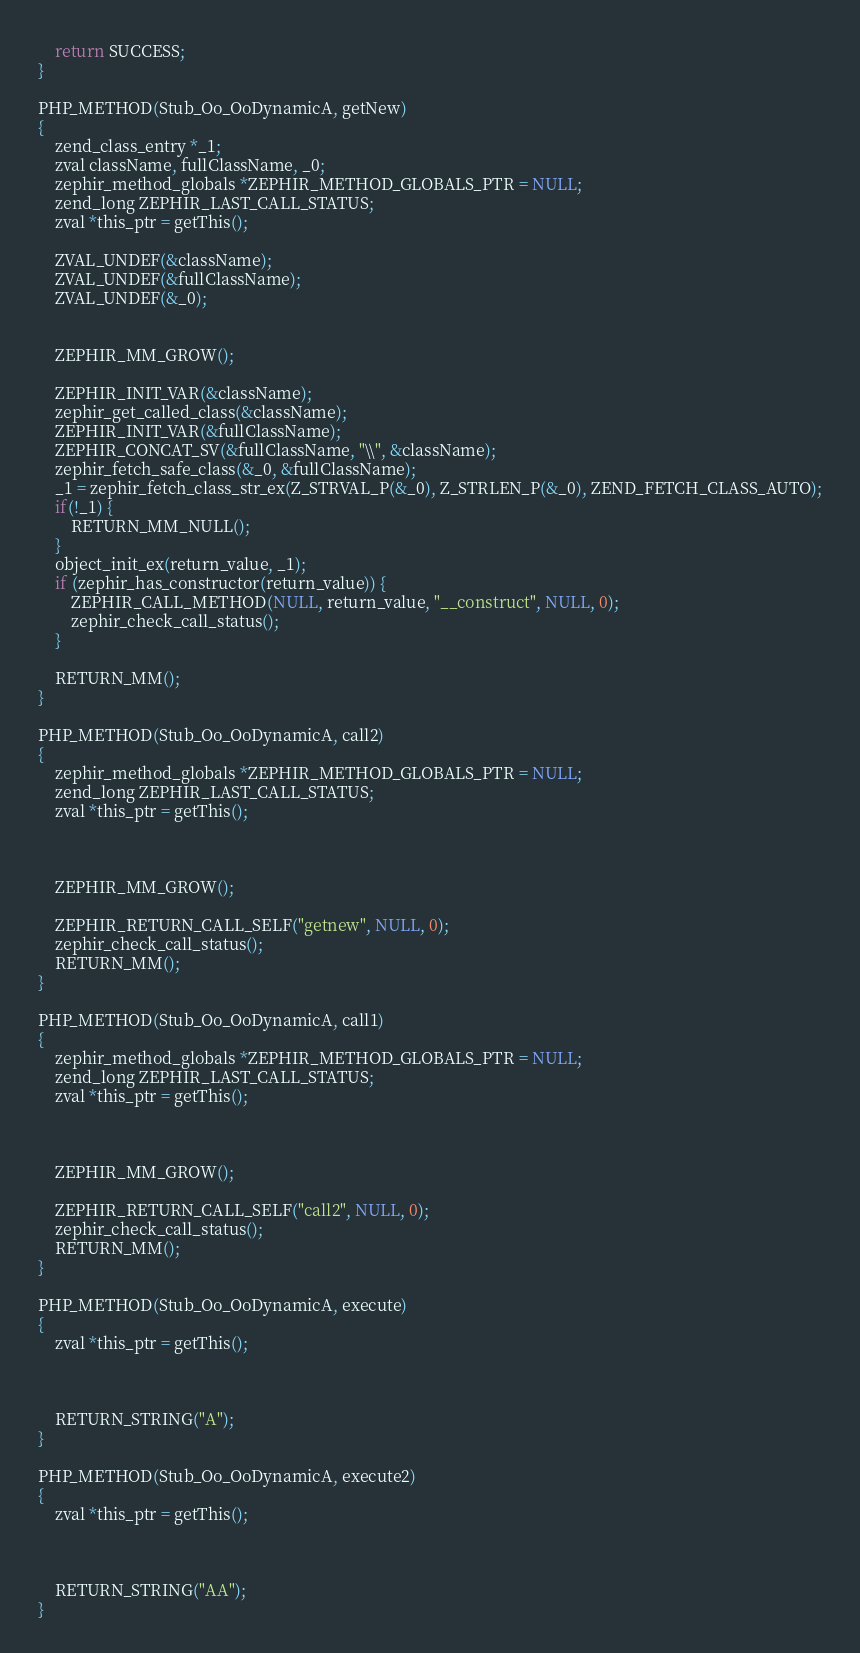Convert code to text. <code><loc_0><loc_0><loc_500><loc_500><_C_>
	return SUCCESS;
}

PHP_METHOD(Stub_Oo_OoDynamicA, getNew)
{
	zend_class_entry *_1;
	zval className, fullClassName, _0;
	zephir_method_globals *ZEPHIR_METHOD_GLOBALS_PTR = NULL;
	zend_long ZEPHIR_LAST_CALL_STATUS;
	zval *this_ptr = getThis();

	ZVAL_UNDEF(&className);
	ZVAL_UNDEF(&fullClassName);
	ZVAL_UNDEF(&_0);


	ZEPHIR_MM_GROW();

	ZEPHIR_INIT_VAR(&className);
	zephir_get_called_class(&className);
	ZEPHIR_INIT_VAR(&fullClassName);
	ZEPHIR_CONCAT_SV(&fullClassName, "\\", &className);
	zephir_fetch_safe_class(&_0, &fullClassName);
	_1 = zephir_fetch_class_str_ex(Z_STRVAL_P(&_0), Z_STRLEN_P(&_0), ZEND_FETCH_CLASS_AUTO);
	if(!_1) {
		RETURN_MM_NULL();
	}
	object_init_ex(return_value, _1);
	if (zephir_has_constructor(return_value)) {
		ZEPHIR_CALL_METHOD(NULL, return_value, "__construct", NULL, 0);
		zephir_check_call_status();
	}

	RETURN_MM();
}

PHP_METHOD(Stub_Oo_OoDynamicA, call2)
{
	zephir_method_globals *ZEPHIR_METHOD_GLOBALS_PTR = NULL;
	zend_long ZEPHIR_LAST_CALL_STATUS;
	zval *this_ptr = getThis();



	ZEPHIR_MM_GROW();

	ZEPHIR_RETURN_CALL_SELF("getnew", NULL, 0);
	zephir_check_call_status();
	RETURN_MM();
}

PHP_METHOD(Stub_Oo_OoDynamicA, call1)
{
	zephir_method_globals *ZEPHIR_METHOD_GLOBALS_PTR = NULL;
	zend_long ZEPHIR_LAST_CALL_STATUS;
	zval *this_ptr = getThis();



	ZEPHIR_MM_GROW();

	ZEPHIR_RETURN_CALL_SELF("call2", NULL, 0);
	zephir_check_call_status();
	RETURN_MM();
}

PHP_METHOD(Stub_Oo_OoDynamicA, execute)
{
	zval *this_ptr = getThis();



	RETURN_STRING("A");
}

PHP_METHOD(Stub_Oo_OoDynamicA, execute2)
{
	zval *this_ptr = getThis();



	RETURN_STRING("AA");
}

</code> 